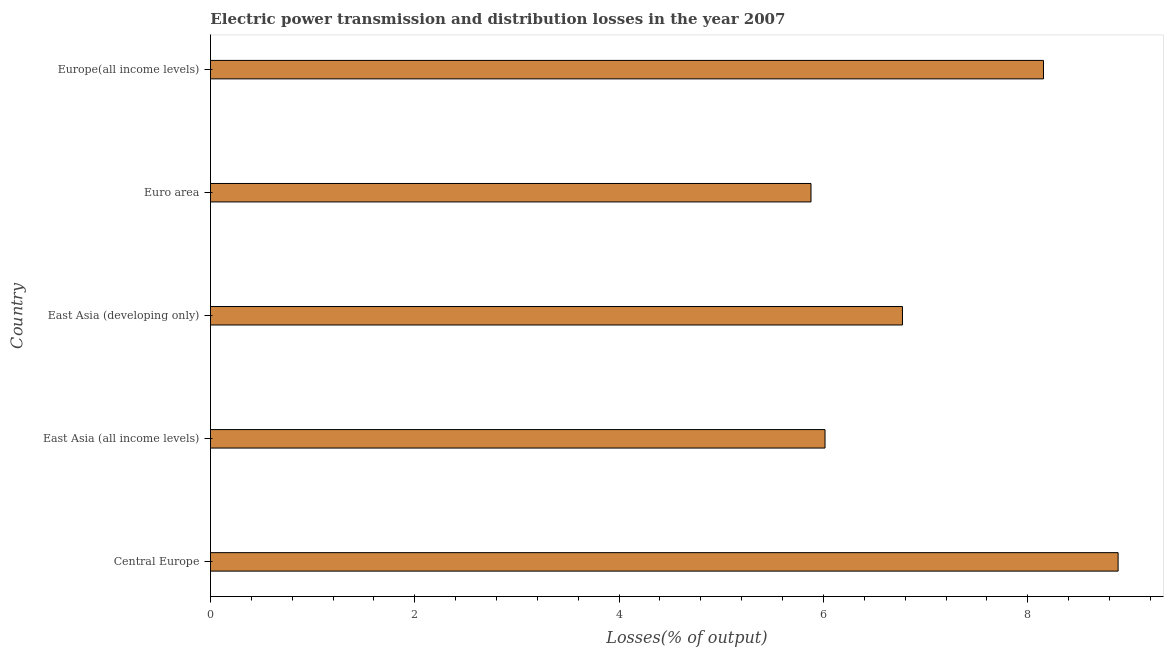What is the title of the graph?
Your answer should be compact. Electric power transmission and distribution losses in the year 2007. What is the label or title of the X-axis?
Your answer should be compact. Losses(% of output). What is the electric power transmission and distribution losses in East Asia (all income levels)?
Keep it short and to the point. 6.02. Across all countries, what is the maximum electric power transmission and distribution losses?
Offer a very short reply. 8.88. Across all countries, what is the minimum electric power transmission and distribution losses?
Ensure brevity in your answer.  5.88. In which country was the electric power transmission and distribution losses maximum?
Your answer should be compact. Central Europe. What is the sum of the electric power transmission and distribution losses?
Make the answer very short. 35.71. What is the difference between the electric power transmission and distribution losses in East Asia (all income levels) and East Asia (developing only)?
Keep it short and to the point. -0.76. What is the average electric power transmission and distribution losses per country?
Provide a succinct answer. 7.14. What is the median electric power transmission and distribution losses?
Provide a short and direct response. 6.77. In how many countries, is the electric power transmission and distribution losses greater than 1.6 %?
Your answer should be compact. 5. What is the ratio of the electric power transmission and distribution losses in East Asia (developing only) to that in Europe(all income levels)?
Provide a short and direct response. 0.83. What is the difference between the highest and the second highest electric power transmission and distribution losses?
Ensure brevity in your answer.  0.73. What is the difference between the highest and the lowest electric power transmission and distribution losses?
Your answer should be compact. 3.01. How many bars are there?
Offer a very short reply. 5. Are all the bars in the graph horizontal?
Keep it short and to the point. Yes. Are the values on the major ticks of X-axis written in scientific E-notation?
Keep it short and to the point. No. What is the Losses(% of output) in Central Europe?
Provide a short and direct response. 8.88. What is the Losses(% of output) in East Asia (all income levels)?
Offer a terse response. 6.02. What is the Losses(% of output) of East Asia (developing only)?
Provide a short and direct response. 6.77. What is the Losses(% of output) of Euro area?
Your response must be concise. 5.88. What is the Losses(% of output) in Europe(all income levels)?
Your response must be concise. 8.15. What is the difference between the Losses(% of output) in Central Europe and East Asia (all income levels)?
Provide a succinct answer. 2.87. What is the difference between the Losses(% of output) in Central Europe and East Asia (developing only)?
Provide a short and direct response. 2.11. What is the difference between the Losses(% of output) in Central Europe and Euro area?
Your response must be concise. 3.01. What is the difference between the Losses(% of output) in Central Europe and Europe(all income levels)?
Your response must be concise. 0.73. What is the difference between the Losses(% of output) in East Asia (all income levels) and East Asia (developing only)?
Your answer should be very brief. -0.76. What is the difference between the Losses(% of output) in East Asia (all income levels) and Euro area?
Your answer should be compact. 0.14. What is the difference between the Losses(% of output) in East Asia (all income levels) and Europe(all income levels)?
Offer a terse response. -2.14. What is the difference between the Losses(% of output) in East Asia (developing only) and Euro area?
Keep it short and to the point. 0.9. What is the difference between the Losses(% of output) in East Asia (developing only) and Europe(all income levels)?
Provide a short and direct response. -1.38. What is the difference between the Losses(% of output) in Euro area and Europe(all income levels)?
Your answer should be compact. -2.28. What is the ratio of the Losses(% of output) in Central Europe to that in East Asia (all income levels)?
Offer a very short reply. 1.48. What is the ratio of the Losses(% of output) in Central Europe to that in East Asia (developing only)?
Provide a short and direct response. 1.31. What is the ratio of the Losses(% of output) in Central Europe to that in Euro area?
Make the answer very short. 1.51. What is the ratio of the Losses(% of output) in Central Europe to that in Europe(all income levels)?
Make the answer very short. 1.09. What is the ratio of the Losses(% of output) in East Asia (all income levels) to that in East Asia (developing only)?
Offer a very short reply. 0.89. What is the ratio of the Losses(% of output) in East Asia (all income levels) to that in Europe(all income levels)?
Provide a short and direct response. 0.74. What is the ratio of the Losses(% of output) in East Asia (developing only) to that in Euro area?
Give a very brief answer. 1.15. What is the ratio of the Losses(% of output) in East Asia (developing only) to that in Europe(all income levels)?
Offer a very short reply. 0.83. What is the ratio of the Losses(% of output) in Euro area to that in Europe(all income levels)?
Offer a terse response. 0.72. 